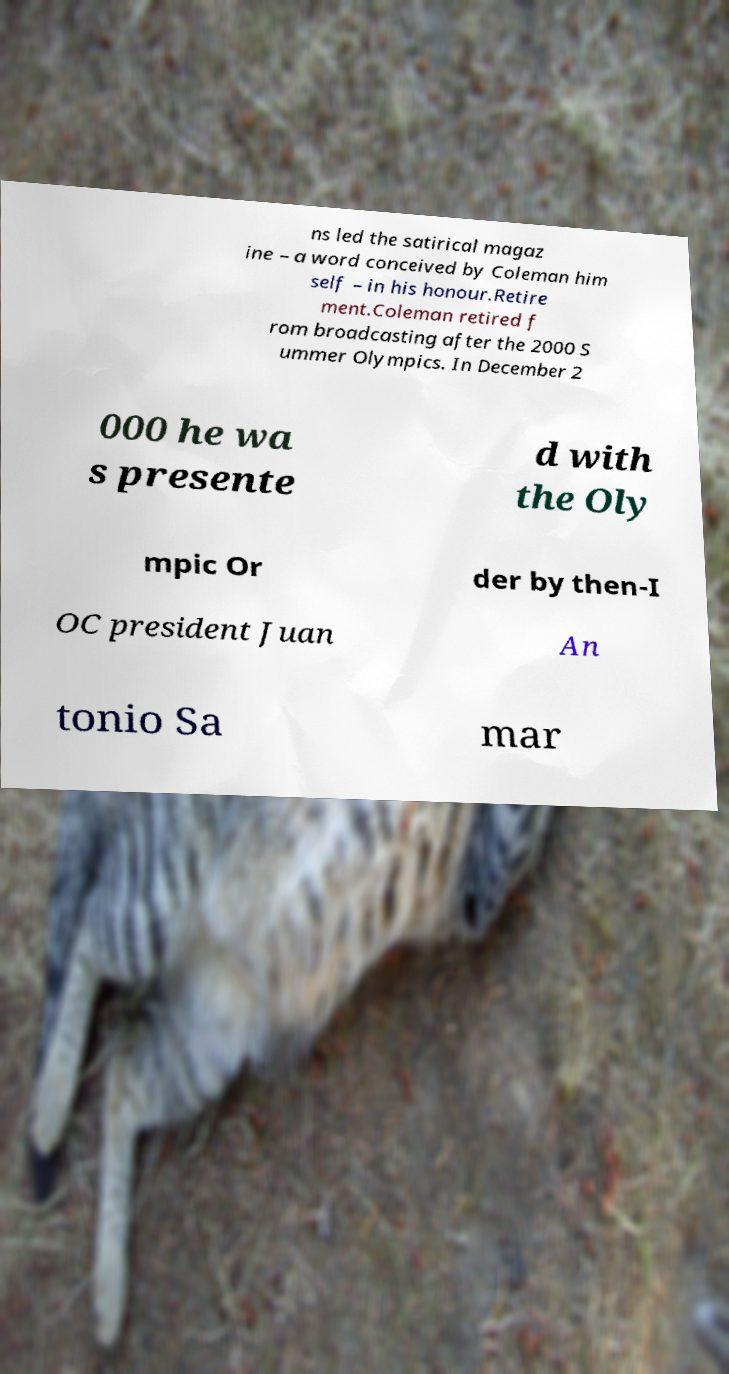Can you read and provide the text displayed in the image?This photo seems to have some interesting text. Can you extract and type it out for me? ns led the satirical magaz ine – a word conceived by Coleman him self – in his honour.Retire ment.Coleman retired f rom broadcasting after the 2000 S ummer Olympics. In December 2 000 he wa s presente d with the Oly mpic Or der by then-I OC president Juan An tonio Sa mar 